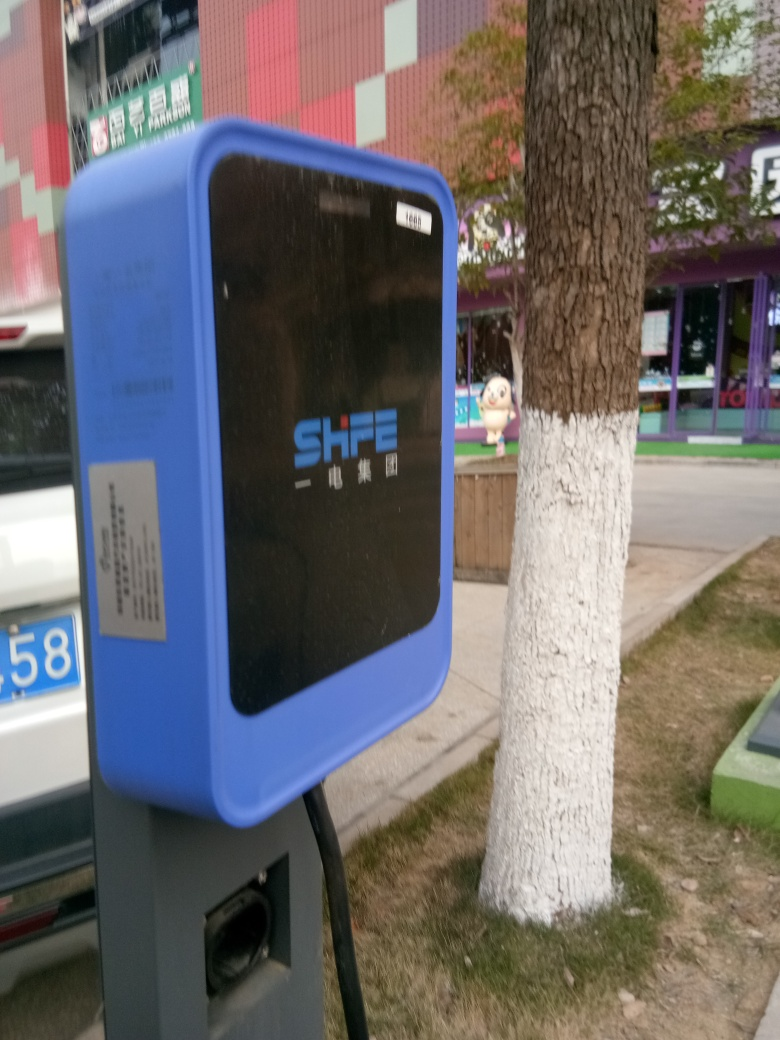Are the shops blurred? The shops in the background are slightly out of focus due to the depth of field effect resulting from the camera settings used when taking the picture. This makes them appear blurred, particularly when comparing with the sharpness of the blue object in the foreground. 